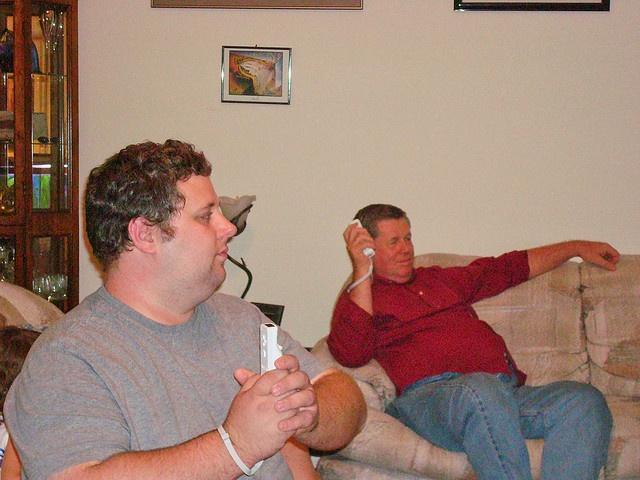Describe the objects in this image and their specific colors. I can see people in maroon, darkgray, salmon, and brown tones, people in maroon, gray, and brown tones, couch in maroon, gray, tan, and brown tones, remote in maroon, lightgray, darkgray, and gray tones, and remote in maroon, darkgray, brown, and lightgray tones in this image. 